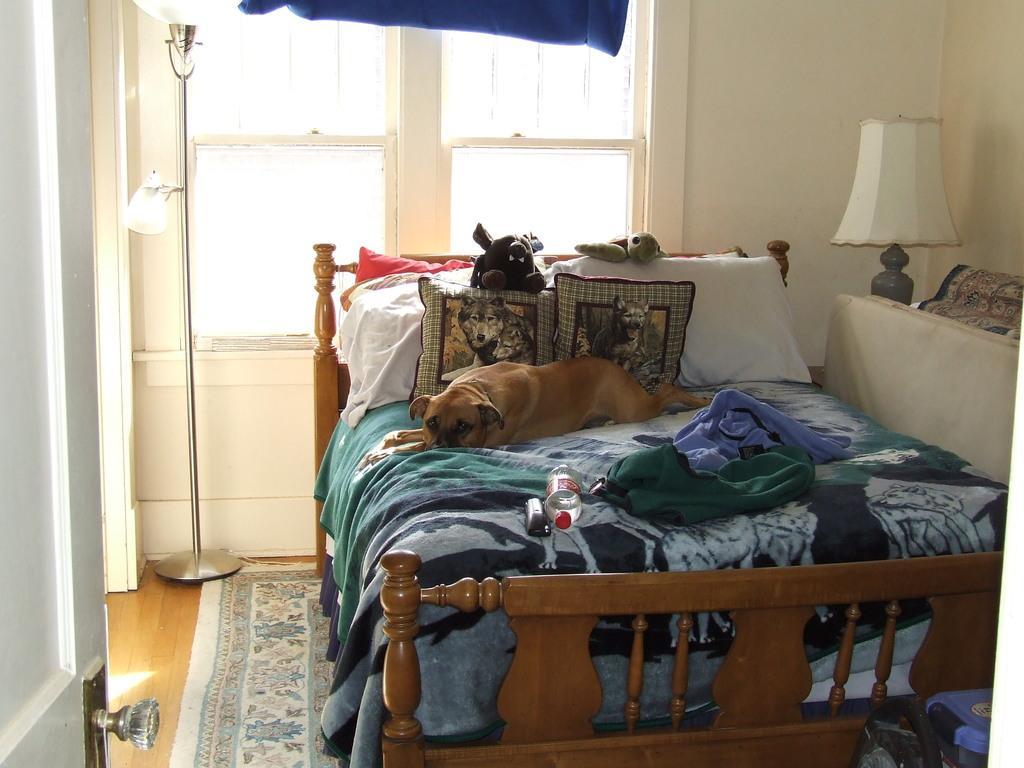Could you give a brief overview of what you see in this image? In the image, there is an inside view of a room. There is a dog on the bed. This bed contains pillows, dolls, bottle and some clothes. There is a light on the top right of the image. There is a door on the left side of the image. There is a window at the top of the image. 